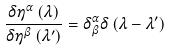<formula> <loc_0><loc_0><loc_500><loc_500>\frac { \delta \eta ^ { \alpha } \left ( \lambda \right ) } { { \delta \eta ^ { \beta } \left ( { \lambda ^ { \prime } } \right ) } } = \delta _ { \beta } ^ { \alpha } \delta \left ( { \lambda - \lambda ^ { \prime } } \right )</formula> 